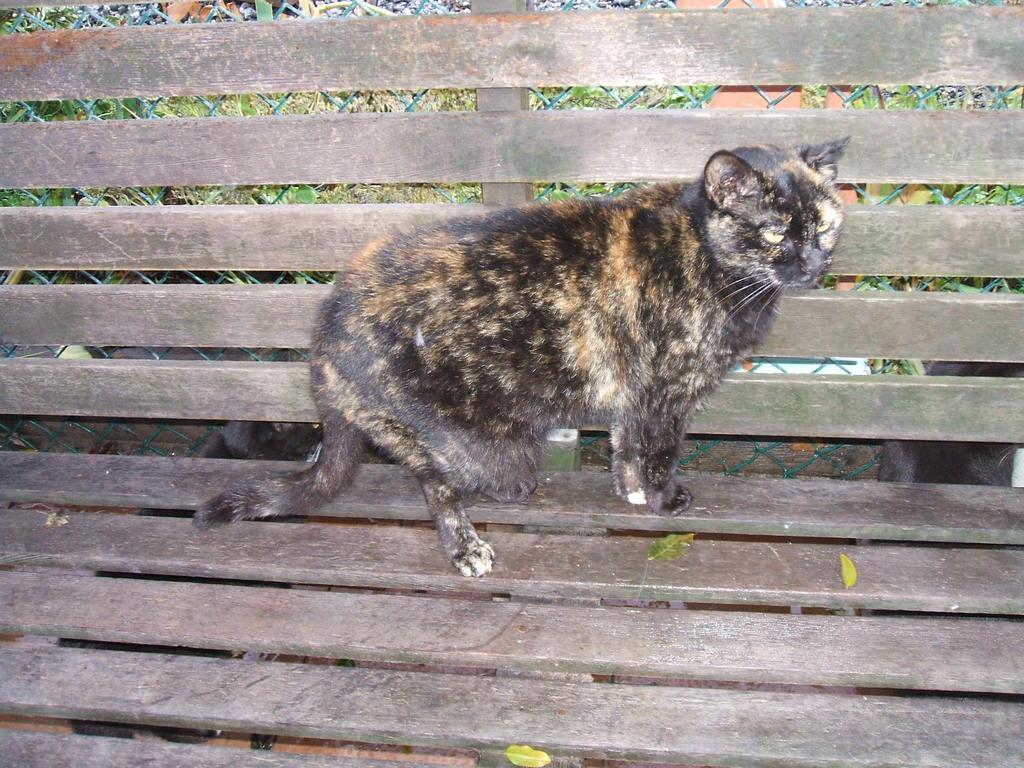Describe this image in one or two sentences. In this image in front there is a cat on the bench. Behind the bench there are two more cats on the floor. 